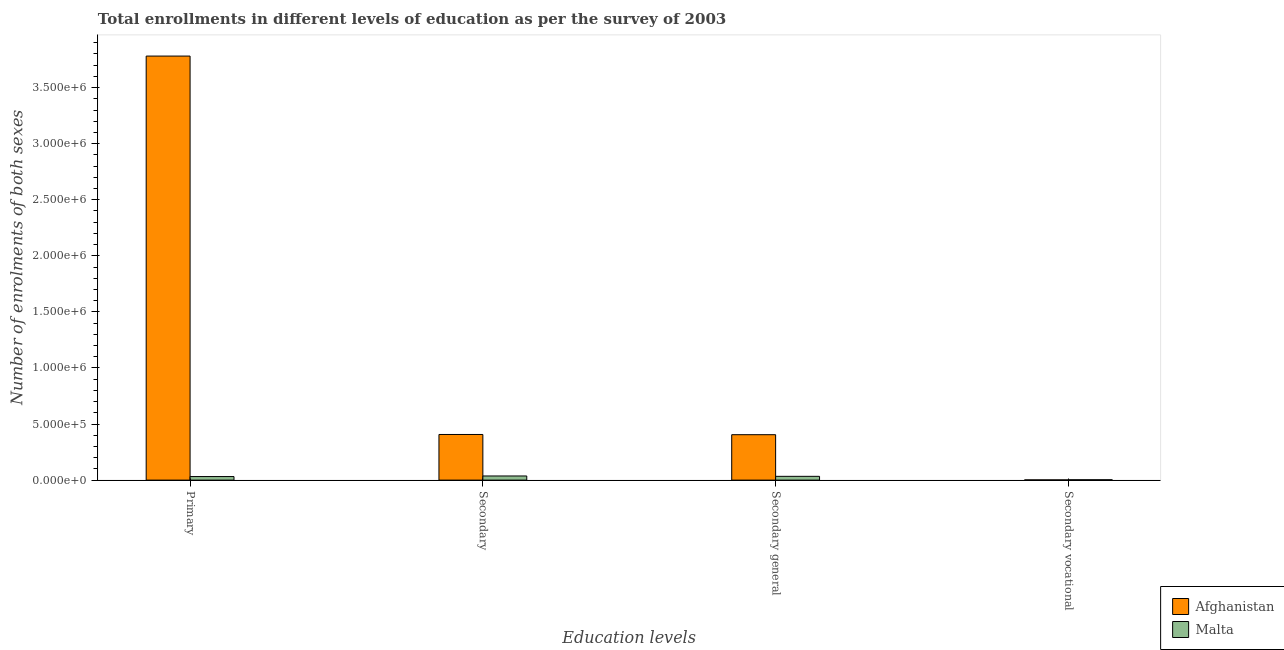How many groups of bars are there?
Your answer should be very brief. 4. How many bars are there on the 3rd tick from the right?
Your answer should be compact. 2. What is the label of the 2nd group of bars from the left?
Your answer should be compact. Secondary. What is the number of enrolments in secondary education in Malta?
Your answer should be compact. 3.70e+04. Across all countries, what is the maximum number of enrolments in secondary vocational education?
Your answer should be compact. 3249. Across all countries, what is the minimum number of enrolments in secondary vocational education?
Provide a succinct answer. 1893. In which country was the number of enrolments in primary education maximum?
Keep it short and to the point. Afghanistan. In which country was the number of enrolments in secondary general education minimum?
Your answer should be very brief. Malta. What is the total number of enrolments in primary education in the graph?
Keep it short and to the point. 3.81e+06. What is the difference between the number of enrolments in primary education in Malta and that in Afghanistan?
Your answer should be compact. -3.75e+06. What is the difference between the number of enrolments in secondary vocational education in Malta and the number of enrolments in primary education in Afghanistan?
Keep it short and to the point. -3.78e+06. What is the average number of enrolments in secondary vocational education per country?
Keep it short and to the point. 2571. What is the difference between the number of enrolments in primary education and number of enrolments in secondary education in Afghanistan?
Keep it short and to the point. 3.37e+06. What is the ratio of the number of enrolments in secondary vocational education in Malta to that in Afghanistan?
Your response must be concise. 1.72. What is the difference between the highest and the second highest number of enrolments in secondary vocational education?
Keep it short and to the point. 1356. What is the difference between the highest and the lowest number of enrolments in secondary general education?
Provide a succinct answer. 3.71e+05. Is the sum of the number of enrolments in primary education in Afghanistan and Malta greater than the maximum number of enrolments in secondary general education across all countries?
Your response must be concise. Yes. What does the 2nd bar from the left in Secondary represents?
Your response must be concise. Malta. What does the 1st bar from the right in Secondary represents?
Offer a very short reply. Malta. Is it the case that in every country, the sum of the number of enrolments in primary education and number of enrolments in secondary education is greater than the number of enrolments in secondary general education?
Give a very brief answer. Yes. How many bars are there?
Ensure brevity in your answer.  8. How many countries are there in the graph?
Provide a short and direct response. 2. What is the difference between two consecutive major ticks on the Y-axis?
Provide a succinct answer. 5.00e+05. Where does the legend appear in the graph?
Your answer should be compact. Bottom right. How are the legend labels stacked?
Ensure brevity in your answer.  Vertical. What is the title of the graph?
Offer a terse response. Total enrollments in different levels of education as per the survey of 2003. What is the label or title of the X-axis?
Your answer should be very brief. Education levels. What is the label or title of the Y-axis?
Give a very brief answer. Number of enrolments of both sexes. What is the Number of enrolments of both sexes of Afghanistan in Primary?
Offer a terse response. 3.78e+06. What is the Number of enrolments of both sexes in Malta in Primary?
Keep it short and to the point. 3.17e+04. What is the Number of enrolments of both sexes in Afghanistan in Secondary?
Your response must be concise. 4.07e+05. What is the Number of enrolments of both sexes in Malta in Secondary?
Provide a short and direct response. 3.70e+04. What is the Number of enrolments of both sexes of Afghanistan in Secondary general?
Your answer should be compact. 4.05e+05. What is the Number of enrolments of both sexes in Malta in Secondary general?
Offer a very short reply. 3.37e+04. What is the Number of enrolments of both sexes of Afghanistan in Secondary vocational?
Your response must be concise. 1893. What is the Number of enrolments of both sexes in Malta in Secondary vocational?
Provide a short and direct response. 3249. Across all Education levels, what is the maximum Number of enrolments of both sexes of Afghanistan?
Give a very brief answer. 3.78e+06. Across all Education levels, what is the maximum Number of enrolments of both sexes in Malta?
Keep it short and to the point. 3.70e+04. Across all Education levels, what is the minimum Number of enrolments of both sexes of Afghanistan?
Provide a short and direct response. 1893. Across all Education levels, what is the minimum Number of enrolments of both sexes of Malta?
Provide a short and direct response. 3249. What is the total Number of enrolments of both sexes of Afghanistan in the graph?
Your answer should be compact. 4.59e+06. What is the total Number of enrolments of both sexes of Malta in the graph?
Give a very brief answer. 1.06e+05. What is the difference between the Number of enrolments of both sexes in Afghanistan in Primary and that in Secondary?
Provide a succinct answer. 3.37e+06. What is the difference between the Number of enrolments of both sexes in Malta in Primary and that in Secondary?
Give a very brief answer. -5268. What is the difference between the Number of enrolments of both sexes of Afghanistan in Primary and that in Secondary general?
Ensure brevity in your answer.  3.38e+06. What is the difference between the Number of enrolments of both sexes of Malta in Primary and that in Secondary general?
Ensure brevity in your answer.  -2019. What is the difference between the Number of enrolments of both sexes in Afghanistan in Primary and that in Secondary vocational?
Your answer should be compact. 3.78e+06. What is the difference between the Number of enrolments of both sexes in Malta in Primary and that in Secondary vocational?
Provide a succinct answer. 2.85e+04. What is the difference between the Number of enrolments of both sexes of Afghanistan in Secondary and that in Secondary general?
Keep it short and to the point. 1893. What is the difference between the Number of enrolments of both sexes of Malta in Secondary and that in Secondary general?
Offer a very short reply. 3249. What is the difference between the Number of enrolments of both sexes in Afghanistan in Secondary and that in Secondary vocational?
Your response must be concise. 4.05e+05. What is the difference between the Number of enrolments of both sexes of Malta in Secondary and that in Secondary vocational?
Your answer should be compact. 3.37e+04. What is the difference between the Number of enrolments of both sexes in Afghanistan in Secondary general and that in Secondary vocational?
Your answer should be compact. 4.03e+05. What is the difference between the Number of enrolments of both sexes of Malta in Secondary general and that in Secondary vocational?
Provide a succinct answer. 3.05e+04. What is the difference between the Number of enrolments of both sexes in Afghanistan in Primary and the Number of enrolments of both sexes in Malta in Secondary?
Offer a terse response. 3.74e+06. What is the difference between the Number of enrolments of both sexes of Afghanistan in Primary and the Number of enrolments of both sexes of Malta in Secondary general?
Give a very brief answer. 3.75e+06. What is the difference between the Number of enrolments of both sexes of Afghanistan in Primary and the Number of enrolments of both sexes of Malta in Secondary vocational?
Give a very brief answer. 3.78e+06. What is the difference between the Number of enrolments of both sexes of Afghanistan in Secondary and the Number of enrolments of both sexes of Malta in Secondary general?
Provide a short and direct response. 3.73e+05. What is the difference between the Number of enrolments of both sexes in Afghanistan in Secondary and the Number of enrolments of both sexes in Malta in Secondary vocational?
Offer a terse response. 4.04e+05. What is the difference between the Number of enrolments of both sexes in Afghanistan in Secondary general and the Number of enrolments of both sexes in Malta in Secondary vocational?
Provide a short and direct response. 4.02e+05. What is the average Number of enrolments of both sexes in Afghanistan per Education levels?
Your answer should be compact. 1.15e+06. What is the average Number of enrolments of both sexes of Malta per Education levels?
Your response must be concise. 2.64e+04. What is the difference between the Number of enrolments of both sexes of Afghanistan and Number of enrolments of both sexes of Malta in Primary?
Provide a succinct answer. 3.75e+06. What is the difference between the Number of enrolments of both sexes of Afghanistan and Number of enrolments of both sexes of Malta in Secondary?
Offer a terse response. 3.70e+05. What is the difference between the Number of enrolments of both sexes in Afghanistan and Number of enrolments of both sexes in Malta in Secondary general?
Provide a succinct answer. 3.71e+05. What is the difference between the Number of enrolments of both sexes of Afghanistan and Number of enrolments of both sexes of Malta in Secondary vocational?
Make the answer very short. -1356. What is the ratio of the Number of enrolments of both sexes in Afghanistan in Primary to that in Secondary?
Make the answer very short. 9.29. What is the ratio of the Number of enrolments of both sexes in Malta in Primary to that in Secondary?
Offer a terse response. 0.86. What is the ratio of the Number of enrolments of both sexes of Afghanistan in Primary to that in Secondary general?
Ensure brevity in your answer.  9.34. What is the ratio of the Number of enrolments of both sexes in Malta in Primary to that in Secondary general?
Keep it short and to the point. 0.94. What is the ratio of the Number of enrolments of both sexes in Afghanistan in Primary to that in Secondary vocational?
Provide a succinct answer. 1997.37. What is the ratio of the Number of enrolments of both sexes of Malta in Primary to that in Secondary vocational?
Provide a short and direct response. 9.76. What is the ratio of the Number of enrolments of both sexes in Malta in Secondary to that in Secondary general?
Keep it short and to the point. 1.1. What is the ratio of the Number of enrolments of both sexes in Afghanistan in Secondary to that in Secondary vocational?
Give a very brief answer. 214.95. What is the ratio of the Number of enrolments of both sexes of Malta in Secondary to that in Secondary vocational?
Your answer should be very brief. 11.38. What is the ratio of the Number of enrolments of both sexes in Afghanistan in Secondary general to that in Secondary vocational?
Ensure brevity in your answer.  213.95. What is the ratio of the Number of enrolments of both sexes of Malta in Secondary general to that in Secondary vocational?
Offer a very short reply. 10.38. What is the difference between the highest and the second highest Number of enrolments of both sexes of Afghanistan?
Your response must be concise. 3.37e+06. What is the difference between the highest and the second highest Number of enrolments of both sexes in Malta?
Offer a terse response. 3249. What is the difference between the highest and the lowest Number of enrolments of both sexes of Afghanistan?
Your answer should be compact. 3.78e+06. What is the difference between the highest and the lowest Number of enrolments of both sexes in Malta?
Give a very brief answer. 3.37e+04. 